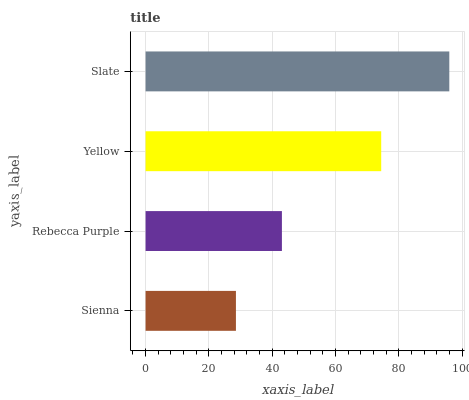Is Sienna the minimum?
Answer yes or no. Yes. Is Slate the maximum?
Answer yes or no. Yes. Is Rebecca Purple the minimum?
Answer yes or no. No. Is Rebecca Purple the maximum?
Answer yes or no. No. Is Rebecca Purple greater than Sienna?
Answer yes or no. Yes. Is Sienna less than Rebecca Purple?
Answer yes or no. Yes. Is Sienna greater than Rebecca Purple?
Answer yes or no. No. Is Rebecca Purple less than Sienna?
Answer yes or no. No. Is Yellow the high median?
Answer yes or no. Yes. Is Rebecca Purple the low median?
Answer yes or no. Yes. Is Rebecca Purple the high median?
Answer yes or no. No. Is Sienna the low median?
Answer yes or no. No. 